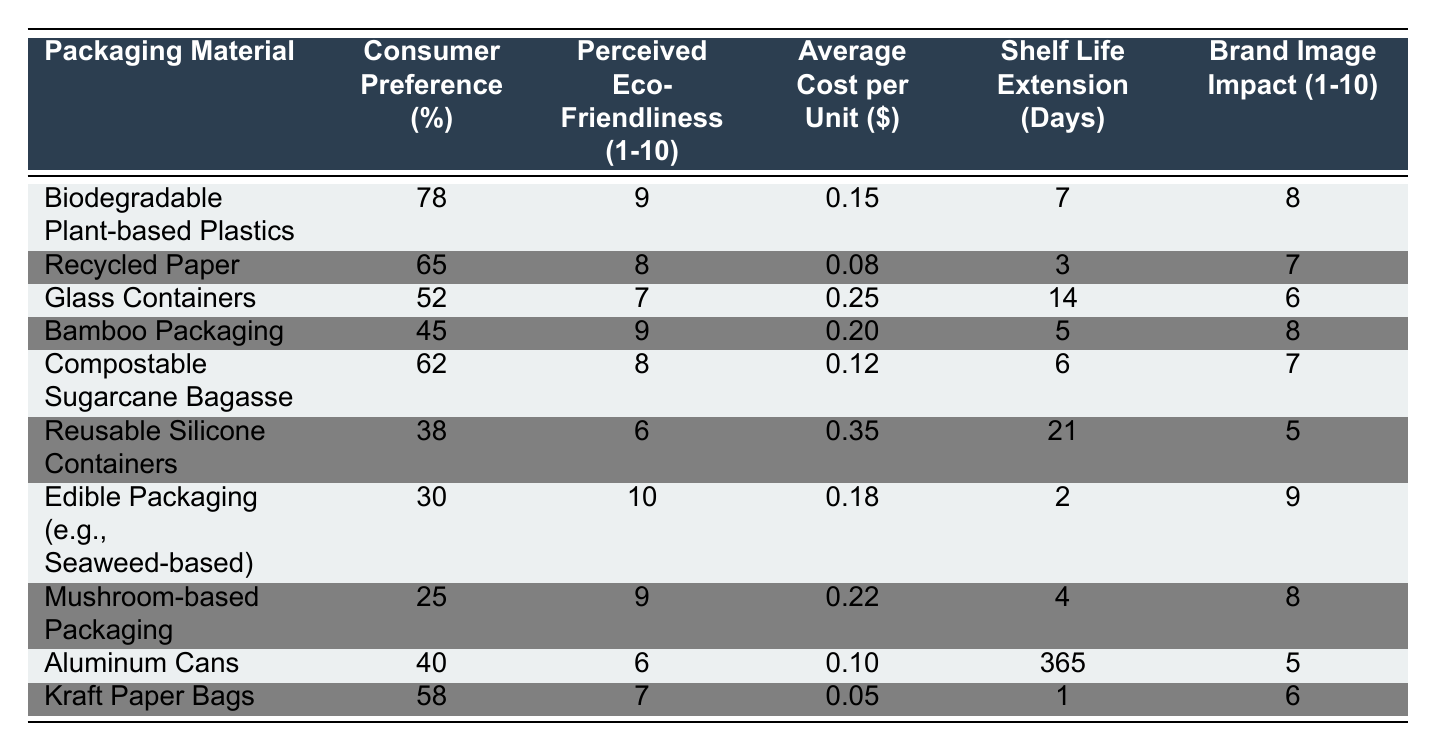What is the consumer preference percentage for biodegradable plant-based plastics? The table shows that the consumer preference percentage for biodegradable plant-based plastics is listed directly. According to the data, it is 78%.
Answer: 78% Which packaging material has the highest perceived eco-friendliness rating? By examining the "Perceived Eco-Friendliness (1-10)" column, biodegradable plant-based plastics and edible packaging both have a rating of 9, meaning they are tied for the highest rating.
Answer: Biodegradable plant-based plastics and edible packaging What is the average cost per unit of recycled paper? The table indicates that the average cost per unit for recycled paper is specified in the corresponding column, which is $0.08.
Answer: $0.08 How many days does the shelf life of aluminum cans extend? The data shows that aluminum cans have a shelf life extension of 365 days, which is directly listed in the table.
Answer: 365 days If we average the brand image impact of bamboo packaging and compostable sugarcane bagasse, what is the result? The brand image impact for bamboo packaging is 8, and for compostable sugarcane bagasse, it is 7. The average can be calculated by adding those two values (8+7=15) and dividing by 2, which gives us 15/2 = 7.5.
Answer: 7.5 Which packaging material is the least preferred by consumers, and what is that percentage? By comparing the consumer preference percentages listed, we see that mushroom-based packaging has the lowest percentage at 25%. Therefore, it is the least preferred.
Answer: Mushroom-based packaging, 25% Is the average cost per unit of reusable silicone containers higher than that of glass containers? The average cost per unit of reusable silicone containers is $0.35, while for glass containers, it is $0.25. Since $0.35 is greater than $0.25, we conclude that the average cost of reusable silicone containers is indeed higher.
Answer: Yes What is the total perceived eco-friendliness score of all packaging materials combined? To find the total score, we add the perceived eco-friendliness ratings: 9 + 8 + 7 + 9 + 8 + 6 + 10 + 9 + 6 + 7 = 78. Hence, the total perceived eco-friendliness score is 78.
Answer: 78 How many more days of shelf life does glass containers provide compared to kraft paper bags? Glass containers have a shelf life extension of 14 days and kraft paper bags have 1 day. The difference is calculated as 14 - 1 = 13 days.
Answer: 13 days Does the consumer preference for bamboo packaging exceed that of edible packaging, and by how much? Bamboo packaging has a consumer preference of 45%, while edible packaging has a preference of 30%. To find the difference, subtract the two percentages: 45 - 30 = 15%. Thus, bamboo packaging exceeds edible packaging by 15%.
Answer: Yes, by 15% 